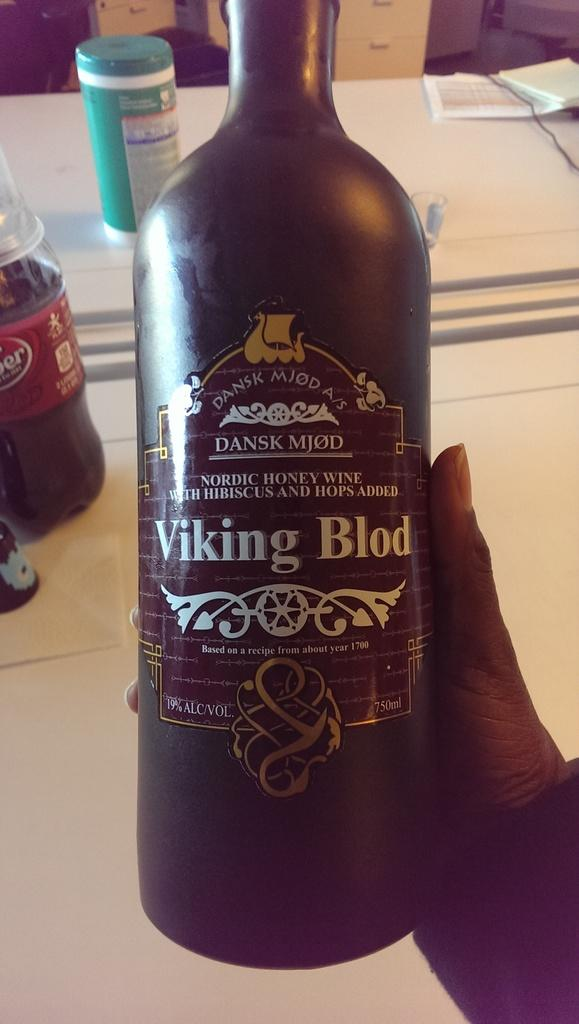Who or what is the main subject in the image? There is a person in the image. What is the person holding in the image? The person is holding a wine bottle. What else can be seen on the table in the image? There are books and a box on the table. Who is the creator of the books on the table in the image? The provided facts do not mention the creator of the books, so it cannot be determined from the image. 